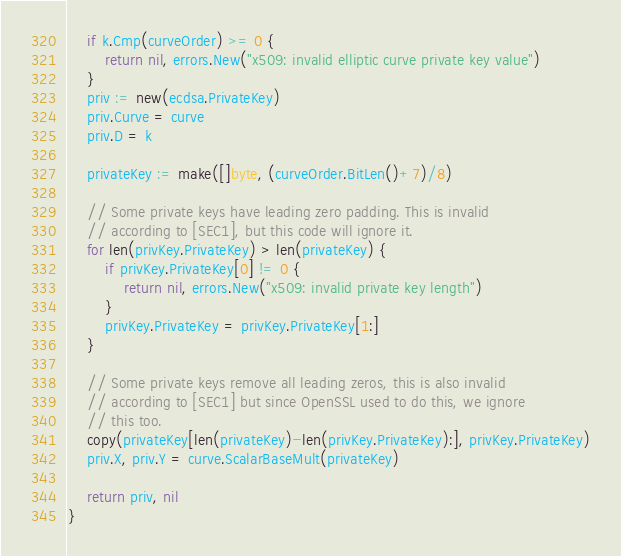<code> <loc_0><loc_0><loc_500><loc_500><_Go_>	if k.Cmp(curveOrder) >= 0 {
		return nil, errors.New("x509: invalid elliptic curve private key value")
	}
	priv := new(ecdsa.PrivateKey)
	priv.Curve = curve
	priv.D = k

	privateKey := make([]byte, (curveOrder.BitLen()+7)/8)

	// Some private keys have leading zero padding. This is invalid
	// according to [SEC1], but this code will ignore it.
	for len(privKey.PrivateKey) > len(privateKey) {
		if privKey.PrivateKey[0] != 0 {
			return nil, errors.New("x509: invalid private key length")
		}
		privKey.PrivateKey = privKey.PrivateKey[1:]
	}

	// Some private keys remove all leading zeros, this is also invalid
	// according to [SEC1] but since OpenSSL used to do this, we ignore
	// this too.
	copy(privateKey[len(privateKey)-len(privKey.PrivateKey):], privKey.PrivateKey)
	priv.X, priv.Y = curve.ScalarBaseMult(privateKey)

	return priv, nil
}
</code> 